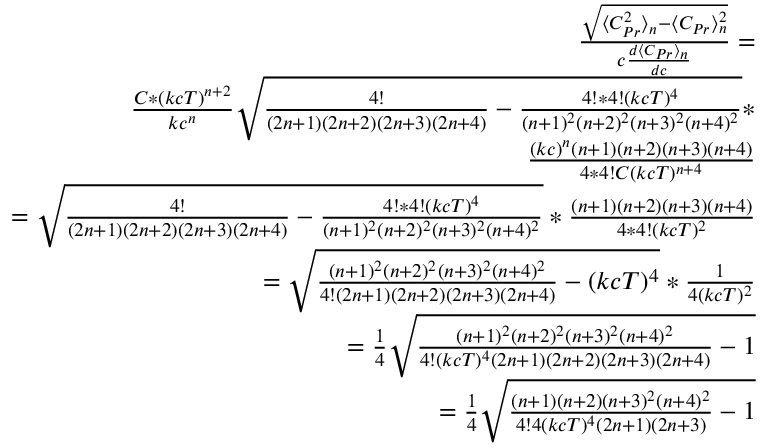<formula> <loc_0><loc_0><loc_500><loc_500>\begin{array} { r } { \frac { \sqrt { \langle C _ { P r } ^ { 2 } \rangle _ { n } - \langle C _ { P r } \rangle _ { n } ^ { 2 } } } { c \frac { d \langle C _ { P r } \rangle _ { n } } { d c } } = } \\ { \frac { C * ( k c T ) ^ { n + 2 } } { k c ^ { n } } \sqrt { \frac { 4 ! } { ( 2 n + 1 ) ( 2 n + 2 ) ( 2 n + 3 ) ( 2 n + 4 ) } - \frac { 4 ! * 4 ! ( k c T ) ^ { 4 } } { ( n + 1 ) ^ { 2 } ( n + 2 ) ^ { 2 } ( n + 3 ) ^ { 2 } ( n + 4 ) ^ { 2 } } } * } \\ { \frac { ( k c ) ^ { n } ( n + 1 ) ( n + 2 ) ( n + 3 ) ( n + 4 ) } { 4 * 4 ! C ( k c T ) ^ { n + 4 } } } \\ { = \sqrt { \frac { 4 ! } { ( 2 n + 1 ) ( 2 n + 2 ) ( 2 n + 3 ) ( 2 n + 4 ) } - \frac { 4 ! * 4 ! ( k c T ) ^ { 4 } } { ( n + 1 ) ^ { 2 } ( n + 2 ) ^ { 2 } ( n + 3 ) ^ { 2 } ( n + 4 ) ^ { 2 } } } * \frac { ( n + 1 ) ( n + 2 ) ( n + 3 ) ( n + 4 ) } { 4 * 4 ! ( k c T ) ^ { 2 } } } \\ { = \sqrt { \frac { ( n + 1 ) ^ { 2 } ( n + 2 ) ^ { 2 } ( n + 3 ) ^ { 2 } ( n + 4 ) ^ { 2 } } { 4 ! ( 2 n + 1 ) ( 2 n + 2 ) ( 2 n + 3 ) ( 2 n + 4 ) } - ( k c T ) ^ { 4 } } * \frac { 1 } { 4 ( k c T ) ^ { 2 } } } \\ { = \frac { 1 } { 4 } \sqrt { \frac { ( n + 1 ) ^ { 2 } ( n + 2 ) ^ { 2 } ( n + 3 ) ^ { 2 } ( n + 4 ) ^ { 2 } } { 4 ! ( k c T ) ^ { 4 } ( 2 n + 1 ) ( 2 n + 2 ) ( 2 n + 3 ) ( 2 n + 4 ) } - 1 } } \\ { = \frac { 1 } { 4 } \sqrt { \frac { ( n + 1 ) ( n + 2 ) ( n + 3 ) ^ { 2 } ( n + 4 ) ^ { 2 } } { 4 ! 4 ( k c T ) ^ { 4 } ( 2 n + 1 ) ( 2 n + 3 ) } - 1 } } \end{array}</formula> 